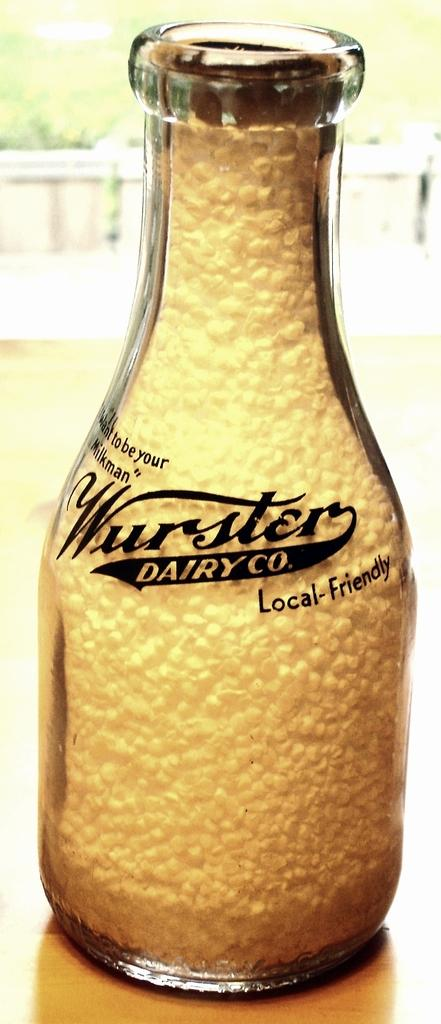<image>
Share a concise interpretation of the image provided. a bottle of the wurster dairy co. local friendly 